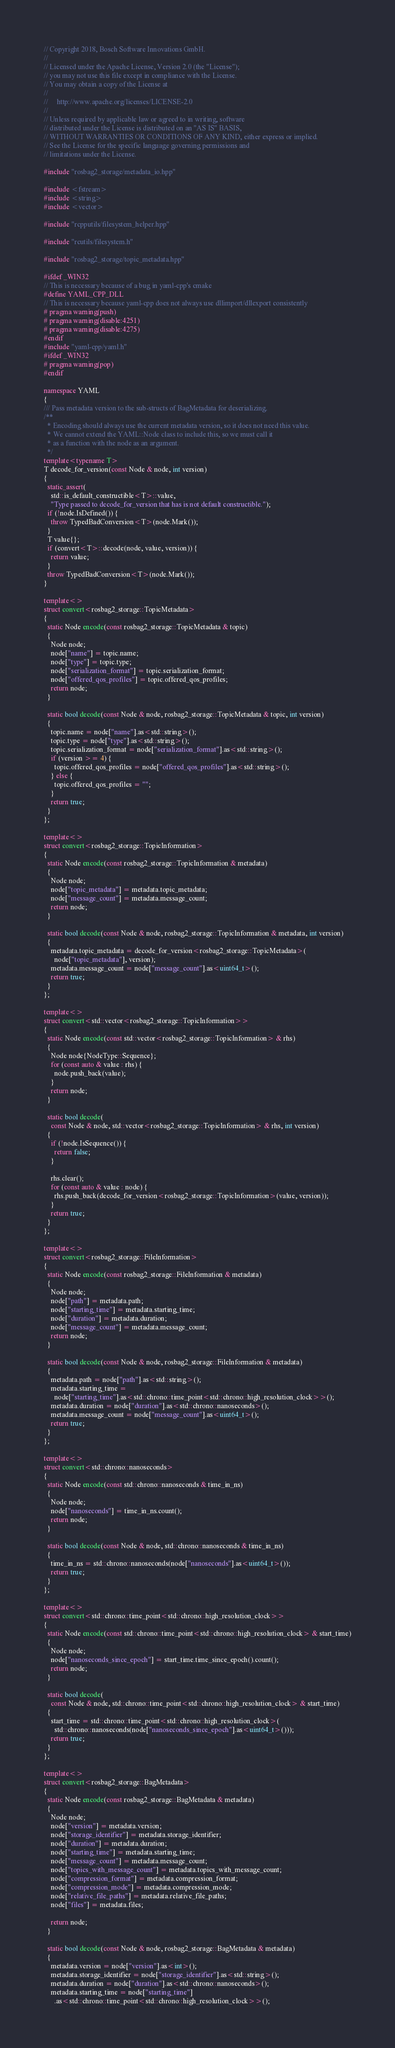<code> <loc_0><loc_0><loc_500><loc_500><_C++_>// Copyright 2018, Bosch Software Innovations GmbH.
//
// Licensed under the Apache License, Version 2.0 (the "License");
// you may not use this file except in compliance with the License.
// You may obtain a copy of the License at
//
//     http://www.apache.org/licenses/LICENSE-2.0
//
// Unless required by applicable law or agreed to in writing, software
// distributed under the License is distributed on an "AS IS" BASIS,
// WITHOUT WARRANTIES OR CONDITIONS OF ANY KIND, either express or implied.
// See the License for the specific language governing permissions and
// limitations under the License.

#include "rosbag2_storage/metadata_io.hpp"

#include <fstream>
#include <string>
#include <vector>

#include "rcpputils/filesystem_helper.hpp"

#include "rcutils/filesystem.h"

#include "rosbag2_storage/topic_metadata.hpp"

#ifdef _WIN32
// This is necessary because of a bug in yaml-cpp's cmake
#define YAML_CPP_DLL
// This is necessary because yaml-cpp does not always use dllimport/dllexport consistently
# pragma warning(push)
# pragma warning(disable:4251)
# pragma warning(disable:4275)
#endif
#include "yaml-cpp/yaml.h"
#ifdef _WIN32
# pragma warning(pop)
#endif

namespace YAML
{
/// Pass metadata version to the sub-structs of BagMetadata for deserializing.
/**
  * Encoding should always use the current metadata version, so it does not need this value.
  * We cannot extend the YAML::Node class to include this, so we must call it
  * as a function with the node as an argument.
  */
template<typename T>
T decode_for_version(const Node & node, int version)
{
  static_assert(
    std::is_default_constructible<T>::value,
    "Type passed to decode_for_version that has is not default constructible.");
  if (!node.IsDefined()) {
    throw TypedBadConversion<T>(node.Mark());
  }
  T value{};
  if (convert<T>::decode(node, value, version)) {
    return value;
  }
  throw TypedBadConversion<T>(node.Mark());
}

template<>
struct convert<rosbag2_storage::TopicMetadata>
{
  static Node encode(const rosbag2_storage::TopicMetadata & topic)
  {
    Node node;
    node["name"] = topic.name;
    node["type"] = topic.type;
    node["serialization_format"] = topic.serialization_format;
    node["offered_qos_profiles"] = topic.offered_qos_profiles;
    return node;
  }

  static bool decode(const Node & node, rosbag2_storage::TopicMetadata & topic, int version)
  {
    topic.name = node["name"].as<std::string>();
    topic.type = node["type"].as<std::string>();
    topic.serialization_format = node["serialization_format"].as<std::string>();
    if (version >= 4) {
      topic.offered_qos_profiles = node["offered_qos_profiles"].as<std::string>();
    } else {
      topic.offered_qos_profiles = "";
    }
    return true;
  }
};

template<>
struct convert<rosbag2_storage::TopicInformation>
{
  static Node encode(const rosbag2_storage::TopicInformation & metadata)
  {
    Node node;
    node["topic_metadata"] = metadata.topic_metadata;
    node["message_count"] = metadata.message_count;
    return node;
  }

  static bool decode(const Node & node, rosbag2_storage::TopicInformation & metadata, int version)
  {
    metadata.topic_metadata = decode_for_version<rosbag2_storage::TopicMetadata>(
      node["topic_metadata"], version);
    metadata.message_count = node["message_count"].as<uint64_t>();
    return true;
  }
};

template<>
struct convert<std::vector<rosbag2_storage::TopicInformation>>
{
  static Node encode(const std::vector<rosbag2_storage::TopicInformation> & rhs)
  {
    Node node{NodeType::Sequence};
    for (const auto & value : rhs) {
      node.push_back(value);
    }
    return node;
  }

  static bool decode(
    const Node & node, std::vector<rosbag2_storage::TopicInformation> & rhs, int version)
  {
    if (!node.IsSequence()) {
      return false;
    }

    rhs.clear();
    for (const auto & value : node) {
      rhs.push_back(decode_for_version<rosbag2_storage::TopicInformation>(value, version));
    }
    return true;
  }
};

template<>
struct convert<rosbag2_storage::FileInformation>
{
  static Node encode(const rosbag2_storage::FileInformation & metadata)
  {
    Node node;
    node["path"] = metadata.path;
    node["starting_time"] = metadata.starting_time;
    node["duration"] = metadata.duration;
    node["message_count"] = metadata.message_count;
    return node;
  }

  static bool decode(const Node & node, rosbag2_storage::FileInformation & metadata)
  {
    metadata.path = node["path"].as<std::string>();
    metadata.starting_time =
      node["starting_time"].as<std::chrono::time_point<std::chrono::high_resolution_clock>>();
    metadata.duration = node["duration"].as<std::chrono::nanoseconds>();
    metadata.message_count = node["message_count"].as<uint64_t>();
    return true;
  }
};

template<>
struct convert<std::chrono::nanoseconds>
{
  static Node encode(const std::chrono::nanoseconds & time_in_ns)
  {
    Node node;
    node["nanoseconds"] = time_in_ns.count();
    return node;
  }

  static bool decode(const Node & node, std::chrono::nanoseconds & time_in_ns)
  {
    time_in_ns = std::chrono::nanoseconds(node["nanoseconds"].as<uint64_t>());
    return true;
  }
};

template<>
struct convert<std::chrono::time_point<std::chrono::high_resolution_clock>>
{
  static Node encode(const std::chrono::time_point<std::chrono::high_resolution_clock> & start_time)
  {
    Node node;
    node["nanoseconds_since_epoch"] = start_time.time_since_epoch().count();
    return node;
  }

  static bool decode(
    const Node & node, std::chrono::time_point<std::chrono::high_resolution_clock> & start_time)
  {
    start_time = std::chrono::time_point<std::chrono::high_resolution_clock>(
      std::chrono::nanoseconds(node["nanoseconds_since_epoch"].as<uint64_t>()));
    return true;
  }
};

template<>
struct convert<rosbag2_storage::BagMetadata>
{
  static Node encode(const rosbag2_storage::BagMetadata & metadata)
  {
    Node node;
    node["version"] = metadata.version;
    node["storage_identifier"] = metadata.storage_identifier;
    node["duration"] = metadata.duration;
    node["starting_time"] = metadata.starting_time;
    node["message_count"] = metadata.message_count;
    node["topics_with_message_count"] = metadata.topics_with_message_count;
    node["compression_format"] = metadata.compression_format;
    node["compression_mode"] = metadata.compression_mode;
    node["relative_file_paths"] = metadata.relative_file_paths;
    node["files"] = metadata.files;

    return node;
  }

  static bool decode(const Node & node, rosbag2_storage::BagMetadata & metadata)
  {
    metadata.version = node["version"].as<int>();
    metadata.storage_identifier = node["storage_identifier"].as<std::string>();
    metadata.duration = node["duration"].as<std::chrono::nanoseconds>();
    metadata.starting_time = node["starting_time"]
      .as<std::chrono::time_point<std::chrono::high_resolution_clock>>();</code> 